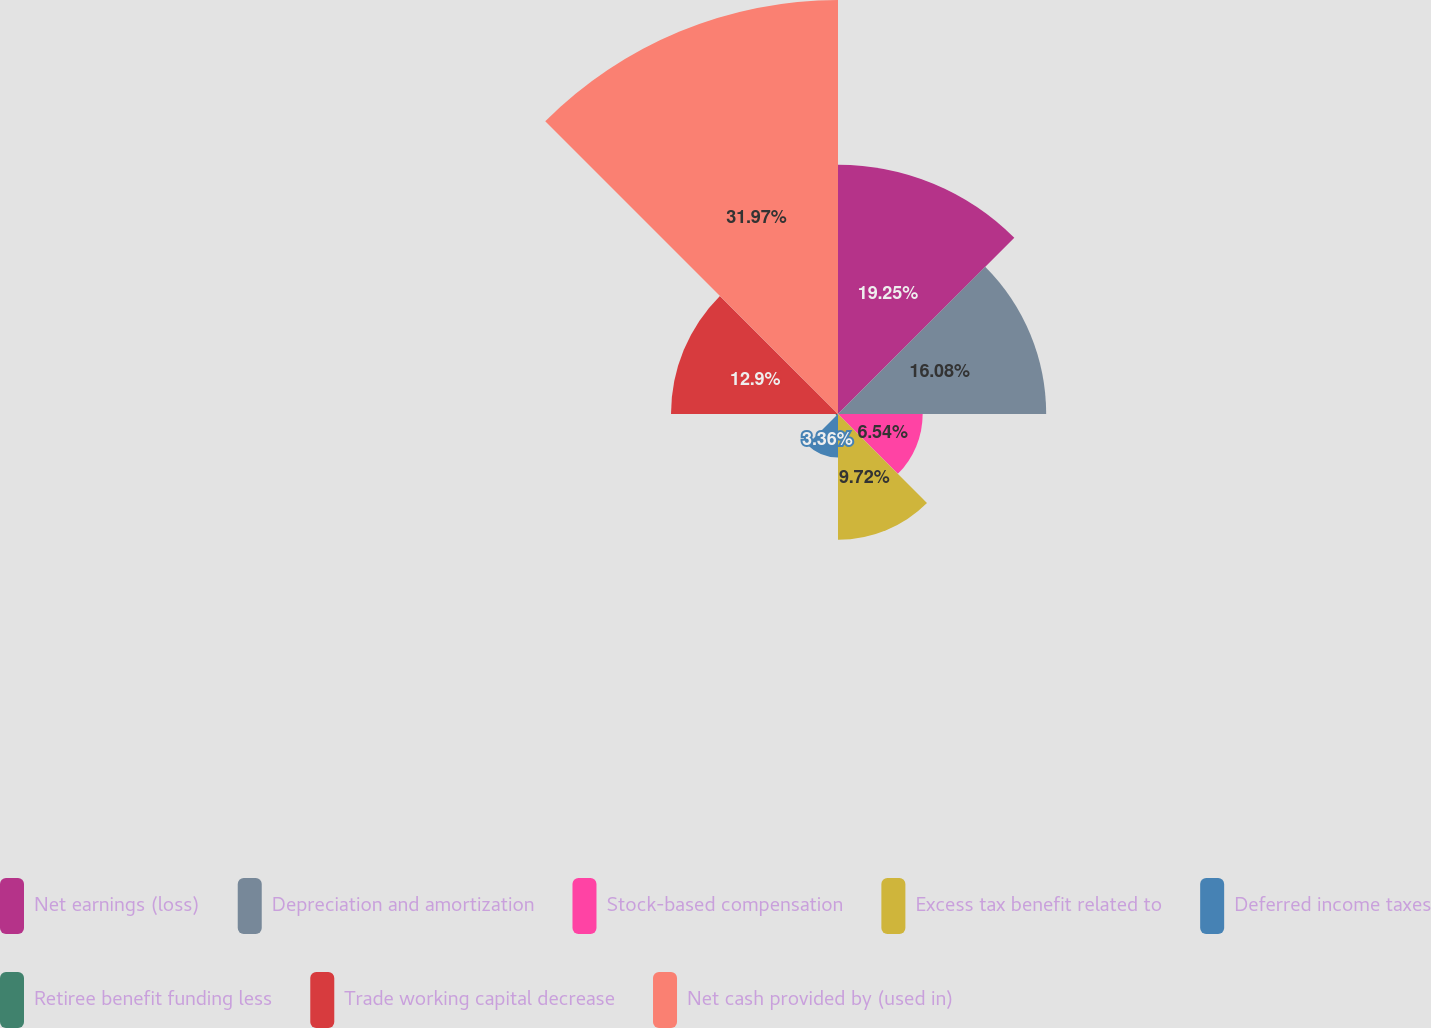Convert chart to OTSL. <chart><loc_0><loc_0><loc_500><loc_500><pie_chart><fcel>Net earnings (loss)<fcel>Depreciation and amortization<fcel>Stock-based compensation<fcel>Excess tax benefit related to<fcel>Deferred income taxes<fcel>Retiree benefit funding less<fcel>Trade working capital decrease<fcel>Net cash provided by (used in)<nl><fcel>19.26%<fcel>16.08%<fcel>6.54%<fcel>9.72%<fcel>3.36%<fcel>0.18%<fcel>12.9%<fcel>31.98%<nl></chart> 